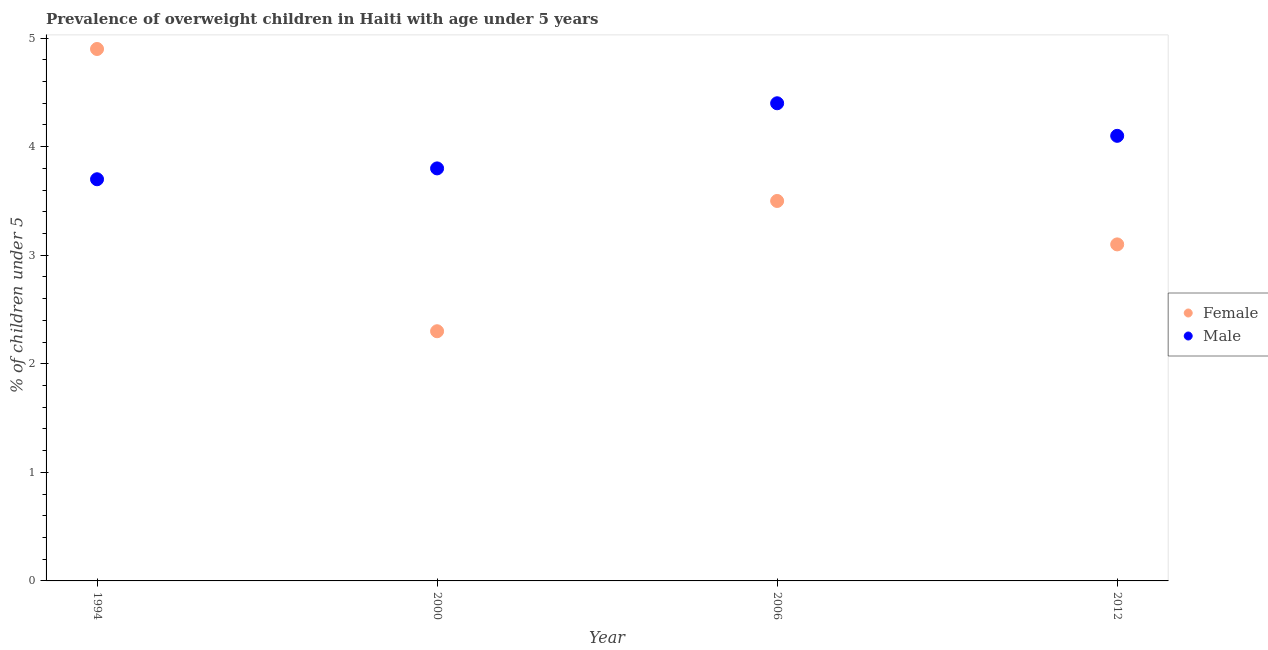Is the number of dotlines equal to the number of legend labels?
Provide a succinct answer. Yes. What is the percentage of obese male children in 1994?
Offer a very short reply. 3.7. Across all years, what is the maximum percentage of obese female children?
Your response must be concise. 4.9. Across all years, what is the minimum percentage of obese female children?
Provide a short and direct response. 2.3. In which year was the percentage of obese male children maximum?
Ensure brevity in your answer.  2006. What is the total percentage of obese female children in the graph?
Provide a short and direct response. 13.8. What is the difference between the percentage of obese female children in 2000 and that in 2012?
Your answer should be very brief. -0.8. What is the average percentage of obese male children per year?
Make the answer very short. 4. In the year 2006, what is the difference between the percentage of obese female children and percentage of obese male children?
Your response must be concise. -0.9. What is the ratio of the percentage of obese male children in 2000 to that in 2012?
Give a very brief answer. 0.93. Is the percentage of obese male children in 2000 less than that in 2012?
Provide a short and direct response. Yes. Is the difference between the percentage of obese male children in 1994 and 2012 greater than the difference between the percentage of obese female children in 1994 and 2012?
Your answer should be very brief. No. What is the difference between the highest and the second highest percentage of obese female children?
Offer a terse response. 1.4. What is the difference between the highest and the lowest percentage of obese male children?
Offer a terse response. 0.7. In how many years, is the percentage of obese female children greater than the average percentage of obese female children taken over all years?
Ensure brevity in your answer.  2. Is the sum of the percentage of obese male children in 2000 and 2006 greater than the maximum percentage of obese female children across all years?
Your response must be concise. Yes. Is the percentage of obese male children strictly less than the percentage of obese female children over the years?
Provide a succinct answer. No. Does the graph contain grids?
Provide a short and direct response. No. Where does the legend appear in the graph?
Offer a terse response. Center right. How many legend labels are there?
Give a very brief answer. 2. How are the legend labels stacked?
Give a very brief answer. Vertical. What is the title of the graph?
Give a very brief answer. Prevalence of overweight children in Haiti with age under 5 years. What is the label or title of the Y-axis?
Ensure brevity in your answer.   % of children under 5. What is the  % of children under 5 of Female in 1994?
Ensure brevity in your answer.  4.9. What is the  % of children under 5 of Male in 1994?
Offer a very short reply. 3.7. What is the  % of children under 5 in Female in 2000?
Provide a short and direct response. 2.3. What is the  % of children under 5 of Male in 2000?
Ensure brevity in your answer.  3.8. What is the  % of children under 5 of Female in 2006?
Offer a very short reply. 3.5. What is the  % of children under 5 in Male in 2006?
Your answer should be very brief. 4.4. What is the  % of children under 5 in Female in 2012?
Your response must be concise. 3.1. What is the  % of children under 5 in Male in 2012?
Ensure brevity in your answer.  4.1. Across all years, what is the maximum  % of children under 5 of Female?
Make the answer very short. 4.9. Across all years, what is the maximum  % of children under 5 of Male?
Make the answer very short. 4.4. Across all years, what is the minimum  % of children under 5 of Female?
Provide a short and direct response. 2.3. Across all years, what is the minimum  % of children under 5 in Male?
Your answer should be compact. 3.7. What is the total  % of children under 5 of Female in the graph?
Give a very brief answer. 13.8. What is the difference between the  % of children under 5 in Female in 1994 and that in 2000?
Your answer should be compact. 2.6. What is the difference between the  % of children under 5 in Male in 1994 and that in 2000?
Make the answer very short. -0.1. What is the difference between the  % of children under 5 in Female in 1994 and that in 2006?
Ensure brevity in your answer.  1.4. What is the difference between the  % of children under 5 of Male in 1994 and that in 2006?
Your answer should be very brief. -0.7. What is the difference between the  % of children under 5 in Female in 2000 and that in 2006?
Keep it short and to the point. -1.2. What is the difference between the  % of children under 5 in Male in 2000 and that in 2006?
Ensure brevity in your answer.  -0.6. What is the difference between the  % of children under 5 in Male in 2000 and that in 2012?
Make the answer very short. -0.3. What is the difference between the  % of children under 5 of Female in 2006 and that in 2012?
Provide a succinct answer. 0.4. What is the difference between the  % of children under 5 in Female in 1994 and the  % of children under 5 in Male in 2012?
Make the answer very short. 0.8. What is the difference between the  % of children under 5 in Female in 2000 and the  % of children under 5 in Male in 2012?
Keep it short and to the point. -1.8. What is the difference between the  % of children under 5 in Female in 2006 and the  % of children under 5 in Male in 2012?
Your answer should be very brief. -0.6. What is the average  % of children under 5 of Female per year?
Offer a terse response. 3.45. What is the average  % of children under 5 of Male per year?
Offer a terse response. 4. In the year 1994, what is the difference between the  % of children under 5 of Female and  % of children under 5 of Male?
Your answer should be compact. 1.2. In the year 2012, what is the difference between the  % of children under 5 of Female and  % of children under 5 of Male?
Give a very brief answer. -1. What is the ratio of the  % of children under 5 of Female in 1994 to that in 2000?
Offer a very short reply. 2.13. What is the ratio of the  % of children under 5 of Male in 1994 to that in 2000?
Ensure brevity in your answer.  0.97. What is the ratio of the  % of children under 5 in Female in 1994 to that in 2006?
Your answer should be very brief. 1.4. What is the ratio of the  % of children under 5 of Male in 1994 to that in 2006?
Your response must be concise. 0.84. What is the ratio of the  % of children under 5 of Female in 1994 to that in 2012?
Make the answer very short. 1.58. What is the ratio of the  % of children under 5 of Male in 1994 to that in 2012?
Provide a short and direct response. 0.9. What is the ratio of the  % of children under 5 of Female in 2000 to that in 2006?
Provide a succinct answer. 0.66. What is the ratio of the  % of children under 5 in Male in 2000 to that in 2006?
Your response must be concise. 0.86. What is the ratio of the  % of children under 5 of Female in 2000 to that in 2012?
Offer a terse response. 0.74. What is the ratio of the  % of children under 5 of Male in 2000 to that in 2012?
Give a very brief answer. 0.93. What is the ratio of the  % of children under 5 in Female in 2006 to that in 2012?
Give a very brief answer. 1.13. What is the ratio of the  % of children under 5 of Male in 2006 to that in 2012?
Give a very brief answer. 1.07. What is the difference between the highest and the second highest  % of children under 5 in Male?
Provide a short and direct response. 0.3. What is the difference between the highest and the lowest  % of children under 5 of Male?
Your response must be concise. 0.7. 